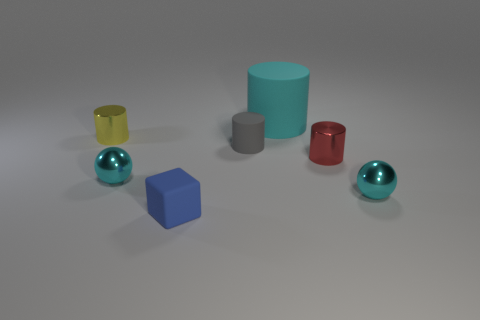There is a cylinder that is made of the same material as the yellow thing; what size is it?
Make the answer very short. Small. Is there anything else that has the same color as the small rubber cylinder?
Provide a succinct answer. No. What is the color of the tiny metal object that is behind the red shiny cylinder?
Keep it short and to the point. Yellow. There is a small cyan shiny thing in front of the tiny cyan sphere to the left of the small gray matte thing; are there any things that are on the right side of it?
Make the answer very short. No. Is the number of big cyan rubber things behind the large thing greater than the number of tiny blue rubber blocks?
Keep it short and to the point. No. There is a small blue matte object on the left side of the large matte cylinder; does it have the same shape as the small gray matte object?
Offer a very short reply. No. Is there anything else that has the same material as the small block?
Provide a succinct answer. Yes. What number of objects are gray objects or small rubber objects left of the gray cylinder?
Give a very brief answer. 2. What is the size of the cylinder that is left of the cyan matte thing and right of the blue cube?
Give a very brief answer. Small. Is the number of cyan balls that are left of the small red cylinder greater than the number of cyan shiny things that are to the left of the yellow object?
Provide a succinct answer. Yes. 